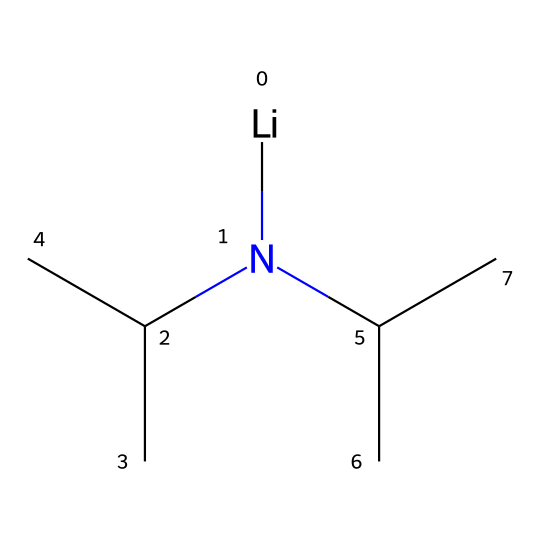What is the molecular formula of lithium diisopropylamide? The SMILES representation indicates the presence of lithium (Li), nitrogen (N), and carbon (C) atoms. Counting the groups, there are two isopropyl groups (each has three carbons) and one lithium and one nitrogen, giving us the formula C6H14NLi.
Answer: C6H14NLi How many carbon atoms are present in the molecule? By analyzing the SMILES, we see that each isopropyl group contributes three carbon atoms, and there are two such groups, totaling six carbon atoms.
Answer: 6 What type of base is lithium diisopropylamide? Lithium diisopropylamide is classified as a superbasic amide because it contains a nitrogen atom bonded to alkyl groups, which makes it very basic and good for deprotonation reactions.
Answer: superbasic What is the hybridization of the nitrogen atom in this compound? The nitrogen in lithium diisopropylamide is bonded to two carbon atoms and has a lone pair, which typically results in sp2 hybridization as nitrogen forms three sp2 hybrid orbitals for bonding and keeps the lone pair.
Answer: sp2 Does lithium diisopropylamide display any steric hindrance? Yes, steric hindrance is present due to the two bulky isopropyl groups around the nitrogen atom, making it less accessible for reactions compared to less hindered bases.
Answer: yes How many hydrogen atoms are connected to the nitrogen atom? In the structure of lithium diisopropylamide, nitrogen is not attached to any hydrogen atoms; instead, it forms four bonds (two with carbon and the other with lithium).
Answer: 0 What role does lithium play in the molecular structure? Lithium serves as a cation which stabilizes the anionic character of the nitrogen, enhancing the basicity of the molecule and facilitating nucleophilic reactions in organic synthesis.
Answer: stabilizes anion 